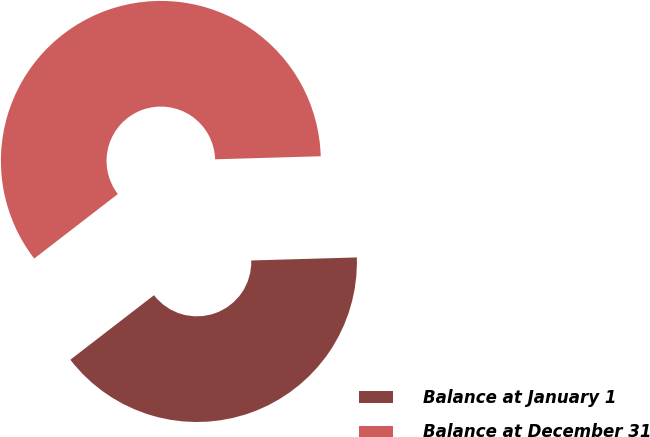Convert chart. <chart><loc_0><loc_0><loc_500><loc_500><pie_chart><fcel>Balance at January 1<fcel>Balance at December 31<nl><fcel>40.0%<fcel>60.0%<nl></chart> 